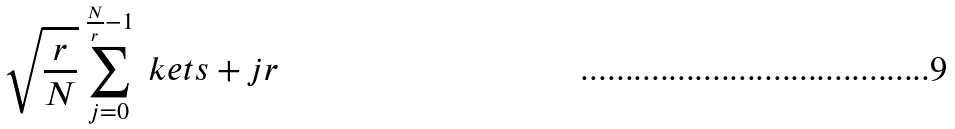Convert formula to latex. <formula><loc_0><loc_0><loc_500><loc_500>\sqrt { \frac { r } { N } } \sum _ { j = { 0 } } ^ { \frac { N } { r } - 1 } \ k e t { s + j r }</formula> 